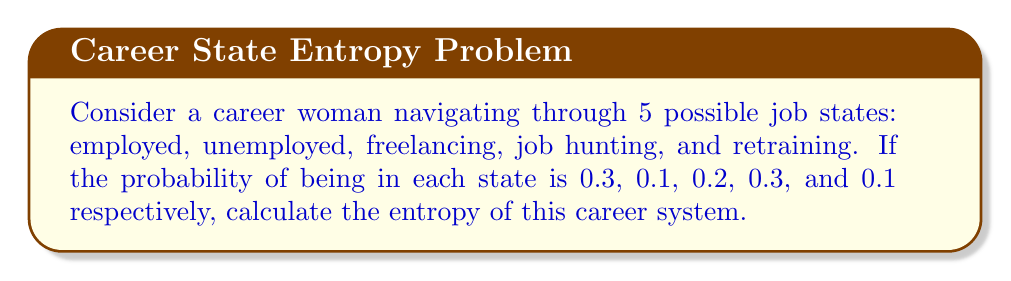Show me your answer to this math problem. To calculate the entropy of this career transition system, we'll use the Shannon entropy formula:

$$ S = -k_B \sum_{i=1}^{n} p_i \ln(p_i) $$

Where:
$S$ is the entropy
$k_B$ is Boltzmann's constant (we'll use 1 for simplicity)
$p_i$ is the probability of being in state $i$
$n$ is the number of possible states (5 in this case)

Step 1: List the probabilities
$p_1 = 0.3$ (employed)
$p_2 = 0.1$ (unemployed)
$p_3 = 0.2$ (freelancing)
$p_4 = 0.3$ (job hunting)
$p_5 = 0.1$ (retraining)

Step 2: Calculate each term in the sum
$-0.3 \ln(0.3) = 0.3612$
$-0.1 \ln(0.1) = 0.2303$
$-0.2 \ln(0.2) = 0.3219$
$-0.3 \ln(0.3) = 0.3612$
$-0.1 \ln(0.1) = 0.2303$

Step 3: Sum all terms
$S = 0.3612 + 0.2303 + 0.3219 + 0.3612 + 0.2303 = 1.5049$

Therefore, the entropy of the career transition system is approximately 1.5049.
Answer: $S \approx 1.5049$ 